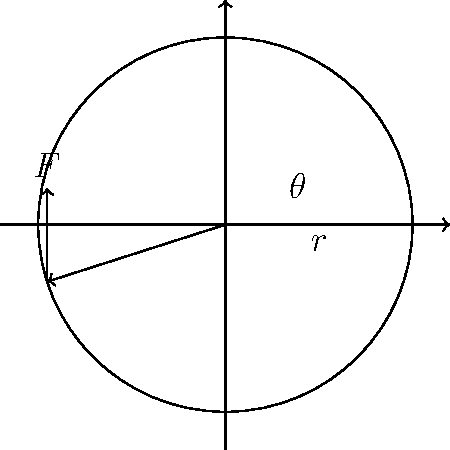A waste sorting machine uses a rotary drum with a radius of 2 meters. If a constant force of 500 N is applied tangentially to the drum's surface, and the angle between the force vector and the horizontal is 60°, what is the magnitude of the torque produced about the drum's axis of rotation? To calculate the torque, we'll follow these steps:

1. Recall the formula for torque:
   $$\tau = r \times F \sin(\theta)$$
   where $\tau$ is torque, $r$ is the radius, $F$ is the force, and $\theta$ is the angle between the radius vector and the force vector.

2. Given information:
   - Radius (r) = 2 meters
   - Force (F) = 500 N
   - Angle between force vector and horizontal = 60°

3. The angle between the radius vector and the force vector is 90° (perpendicular), so $\sin(\theta) = 1$.

4. Substitute the values into the torque equation:
   $$\tau = 2 \text{ m} \times 500 \text{ N} \times 1$$

5. Calculate the result:
   $$\tau = 1000 \text{ N·m}$$

Therefore, the magnitude of the torque produced is 1000 N·m.
Answer: 1000 N·m 